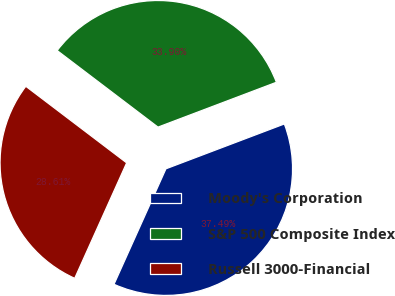<chart> <loc_0><loc_0><loc_500><loc_500><pie_chart><fcel>Moody's Corporation<fcel>S&P 500 Composite Index<fcel>Russell 3000-Financial<nl><fcel>37.49%<fcel>33.9%<fcel>28.61%<nl></chart> 